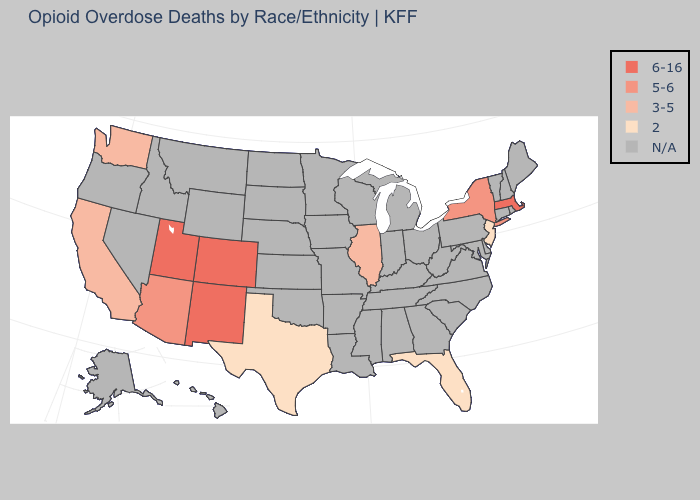What is the lowest value in states that border Arizona?
Answer briefly. 3-5. Which states hav the highest value in the Northeast?
Concise answer only. Massachusetts. Is the legend a continuous bar?
Give a very brief answer. No. What is the value of Florida?
Answer briefly. 2. Name the states that have a value in the range N/A?
Be succinct. Alabama, Alaska, Arkansas, Connecticut, Delaware, Georgia, Hawaii, Idaho, Indiana, Iowa, Kansas, Kentucky, Louisiana, Maine, Maryland, Michigan, Minnesota, Mississippi, Missouri, Montana, Nebraska, Nevada, New Hampshire, North Carolina, North Dakota, Ohio, Oklahoma, Oregon, Pennsylvania, Rhode Island, South Carolina, South Dakota, Tennessee, Vermont, Virginia, West Virginia, Wisconsin, Wyoming. Name the states that have a value in the range 6-16?
Concise answer only. Colorado, Massachusetts, New Mexico, Utah. What is the value of California?
Quick response, please. 3-5. What is the highest value in the USA?
Short answer required. 6-16. What is the highest value in the USA?
Keep it brief. 6-16. What is the highest value in states that border Nevada?
Answer briefly. 6-16. Name the states that have a value in the range 5-6?
Quick response, please. Arizona, New York. What is the value of Kansas?
Be succinct. N/A. Which states hav the highest value in the MidWest?
Keep it brief. Illinois. Which states have the lowest value in the USA?
Short answer required. Florida, New Jersey, Texas. Name the states that have a value in the range 3-5?
Be succinct. California, Illinois, Washington. 